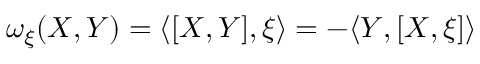Convert formula to latex. <formula><loc_0><loc_0><loc_500><loc_500>\omega _ { \xi } ( X , Y ) = \langle [ X , Y ] , \xi \rangle = - \langle Y , [ X , \xi ] \rangle</formula> 